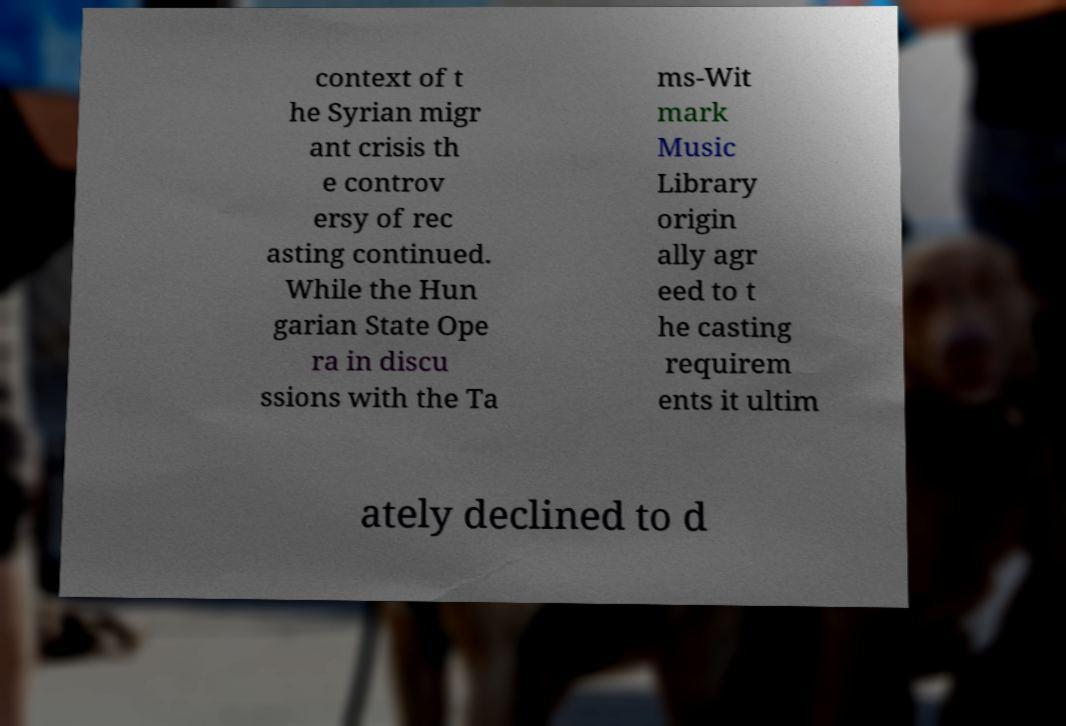For documentation purposes, I need the text within this image transcribed. Could you provide that? context of t he Syrian migr ant crisis th e controv ersy of rec asting continued. While the Hun garian State Ope ra in discu ssions with the Ta ms-Wit mark Music Library origin ally agr eed to t he casting requirem ents it ultim ately declined to d 